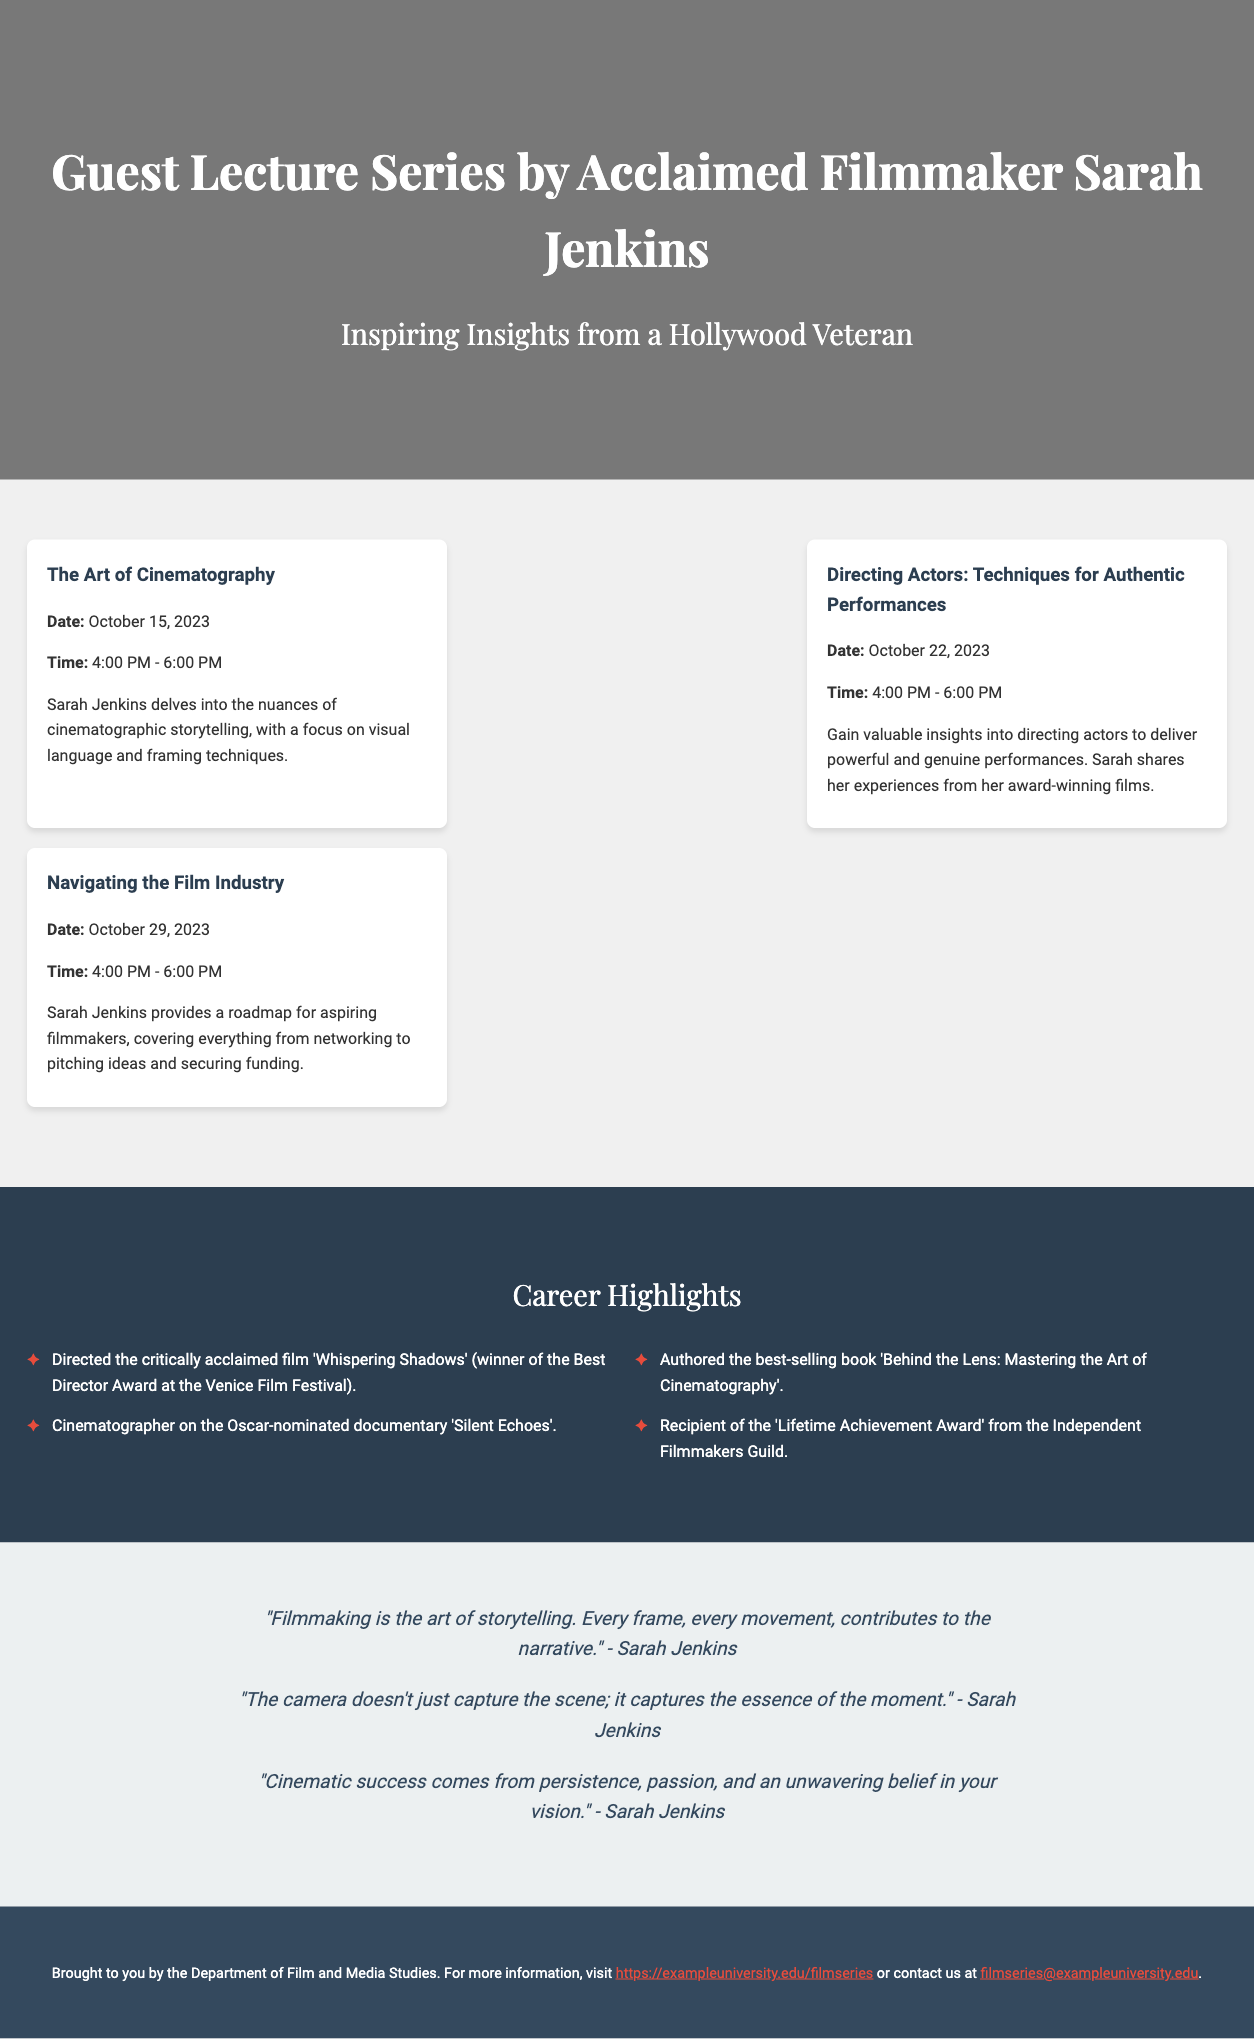What is the name of the guest lecturer? The guest lecturer is Sarah Jenkins, as indicated in the title.
Answer: Sarah Jenkins When is the lecture on "Directing Actors"? The date for the "Directing Actors" lecture is provided in the document.
Answer: October 22, 2023 What is the main focus of the first lecture? The document specifies that the first lecture focuses on cinematographic storytelling.
Answer: Cinematographic storytelling What award did Sarah Jenkins win at the Venice Film Festival? The document mentions a specific award related to a film directed by Sarah Jenkins.
Answer: Best Director Award How many lectures are included in the series? By counting the lectures presented in the document, we can determine the total.
Answer: 3 What is one of the inspirational quotes by Sarah Jenkins? The document contains several quotes, and one can be chosen for this question.
Answer: "Filmmaking is the art of storytelling. Every frame, every movement, contributes to the narrative." What is the title of Sarah Jenkins' best-selling book? A specific book title is listed among her career highlights.
Answer: Behind the Lens: Mastering the Art of Cinematography What organization gave Sarah Jenkins a Lifetime Achievement Award? The document identifies the organization that recognized her contributions to filmmaking.
Answer: Independent Filmmakers Guild What time does the lecture on "Navigating the Film Industry" start? The time for this specific lecture is detailed in the schedule provided in the document.
Answer: 4:00 PM 